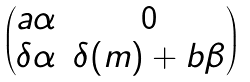Convert formula to latex. <formula><loc_0><loc_0><loc_500><loc_500>\begin{pmatrix} a \alpha & 0 \\ \delta \alpha & \delta ( m ) + b \beta \end{pmatrix}</formula> 